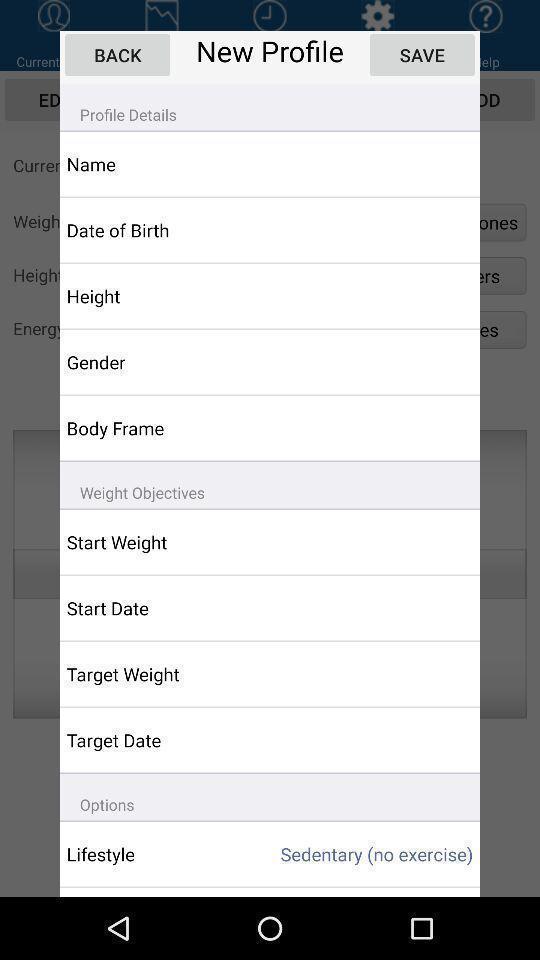What can you discern from this picture? Popup displaying profile options. 